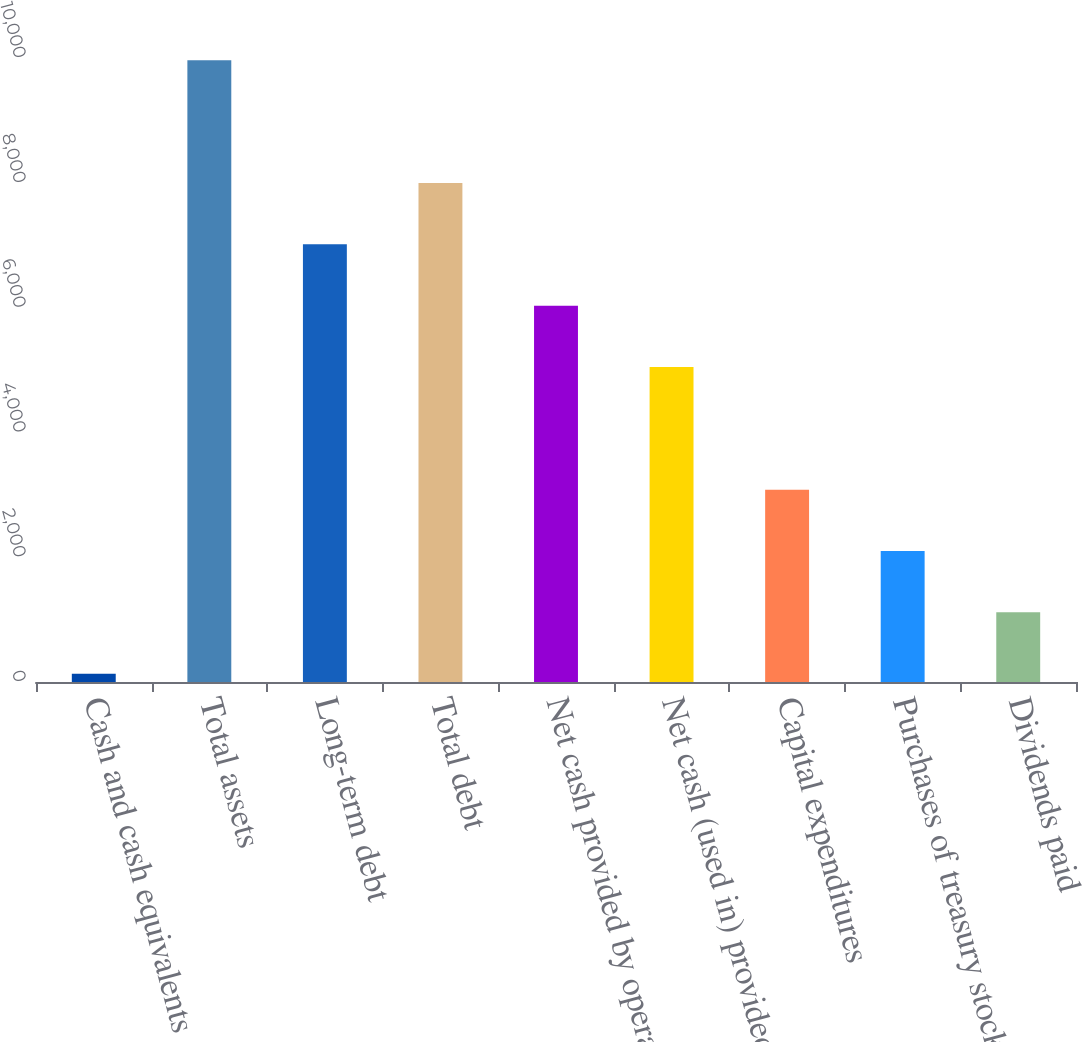Convert chart to OTSL. <chart><loc_0><loc_0><loc_500><loc_500><bar_chart><fcel>Cash and cash equivalents<fcel>Total assets<fcel>Long-term debt<fcel>Total debt<fcel>Net cash provided by operating<fcel>Net cash (used in) provided by<fcel>Capital expenditures<fcel>Purchases of treasury stock<fcel>Dividends paid<nl><fcel>133<fcel>9962<fcel>7013.3<fcel>7996.2<fcel>6030.4<fcel>5047.5<fcel>3081.7<fcel>2098.8<fcel>1115.9<nl></chart> 